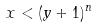<formula> <loc_0><loc_0><loc_500><loc_500>x < ( y + 1 ) ^ { n }</formula> 